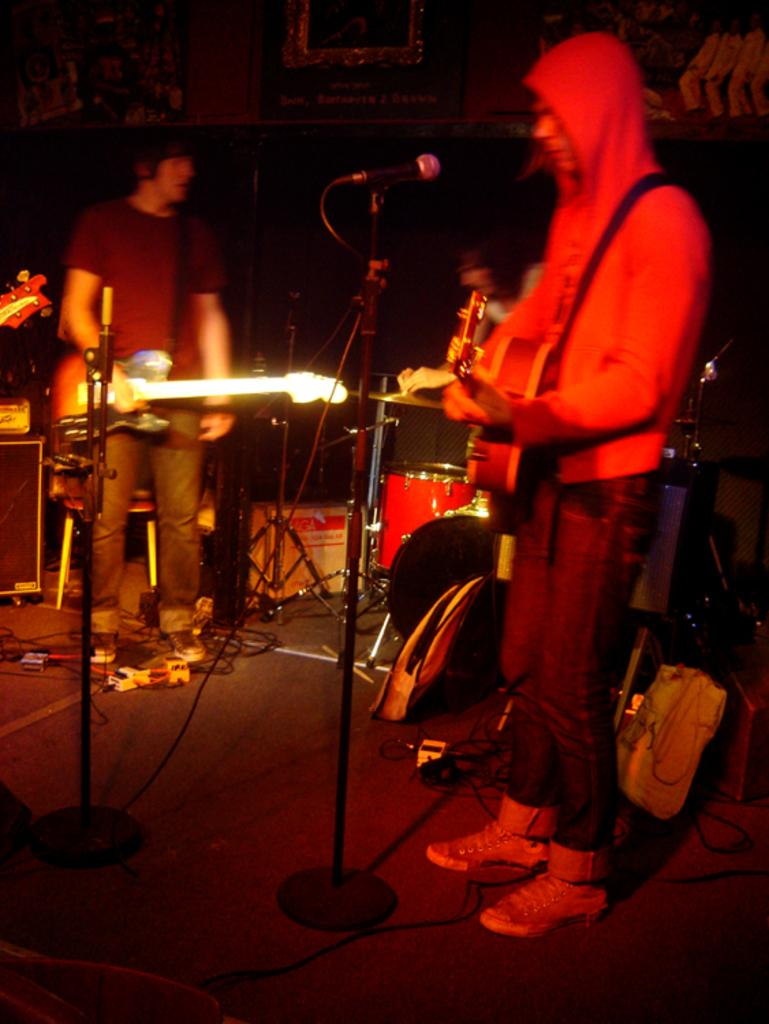How many people are in the image? There are people in the image, but the exact number is not specified. What are the people doing in the image? The people are standing and holding guitars in their hands. What other musical instrument can be seen in the background of the image? There is a drum set in the background of the image. What type of locket is the person wearing around their neck in the image? There is no mention of a locket or any jewelry in the image. Can you tell me how the mother is interacting with the people in the image? There is no mention of a mother or any familial relationships in the image. 